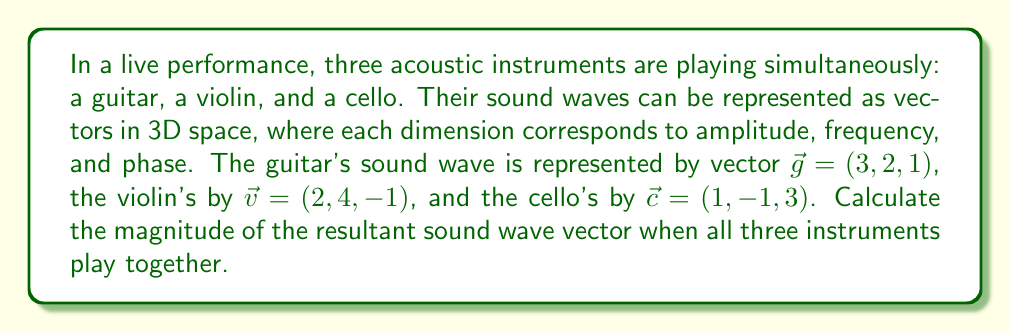Can you answer this question? To solve this problem, we'll follow these steps:

1) The resultant sound wave vector $\vec{r}$ is the sum of the individual vectors:
   $$\vec{r} = \vec{g} + \vec{v} + \vec{c}$$

2) Let's add these vectors:
   $$\vec{r} = (3, 2, 1) + (2, 4, -1) + (1, -1, 3)$$
   $$\vec{r} = (3+2+1, 2+4-1, 1-1+3)$$
   $$\vec{r} = (6, 5, 3)$$

3) To find the magnitude of this resultant vector, we use the Euclidean norm formula:
   $$|\vec{r}| = \sqrt{x^2 + y^2 + z^2}$$
   Where $x$, $y$, and $z$ are the components of the vector.

4) Substituting our values:
   $$|\vec{r}| = \sqrt{6^2 + 5^2 + 3^2}$$

5) Simplify:
   $$|\vec{r}| = \sqrt{36 + 25 + 9}$$
   $$|\vec{r}| = \sqrt{70}$$

Therefore, the magnitude of the resultant sound wave vector is $\sqrt{70}$.
Answer: $\sqrt{70}$ 